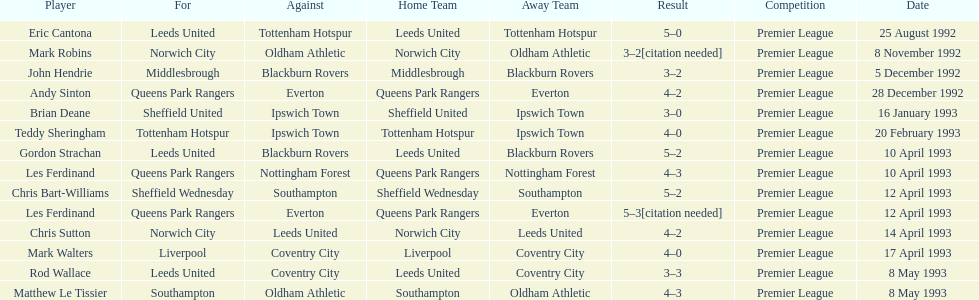How many players were for leeds united? 3. 